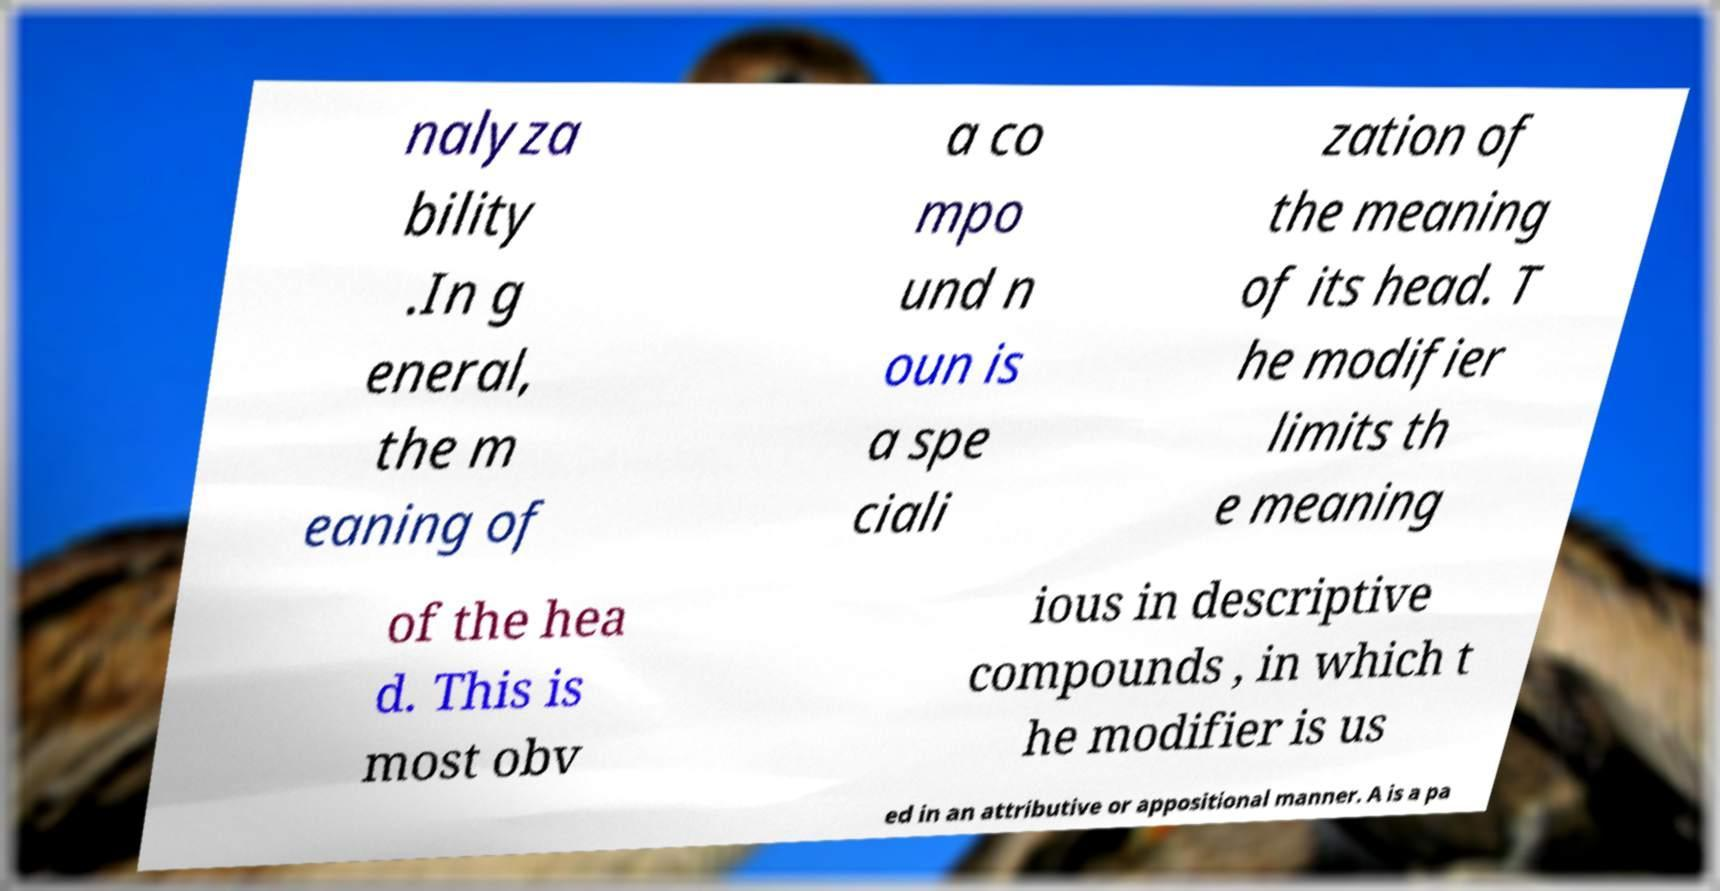There's text embedded in this image that I need extracted. Can you transcribe it verbatim? nalyza bility .In g eneral, the m eaning of a co mpo und n oun is a spe ciali zation of the meaning of its head. T he modifier limits th e meaning of the hea d. This is most obv ious in descriptive compounds , in which t he modifier is us ed in an attributive or appositional manner. A is a pa 